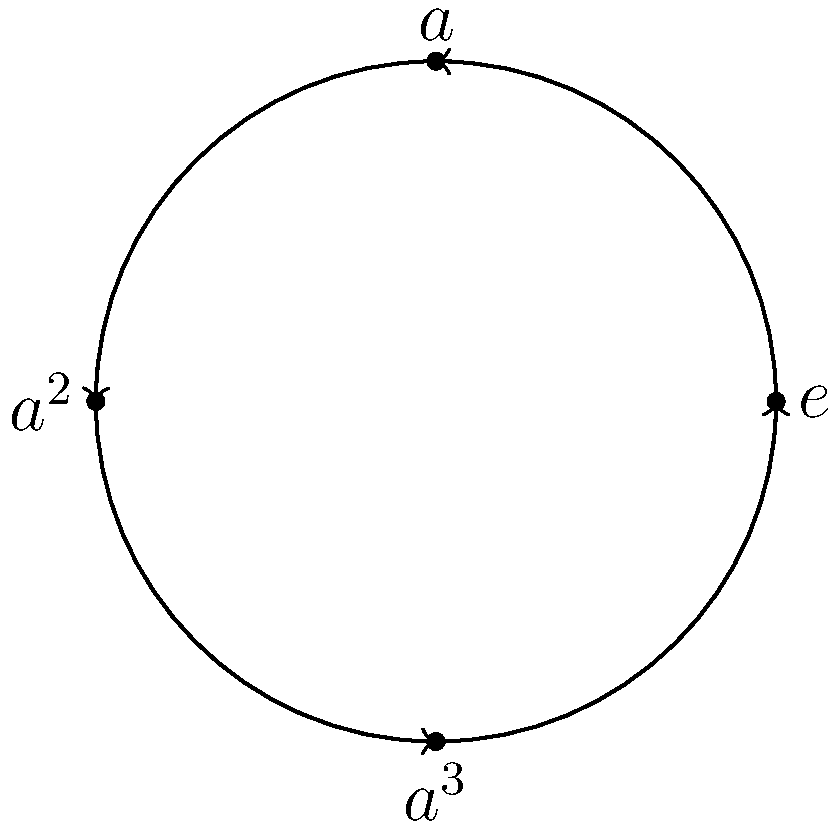In the context of secure software development, consider a cyclic group $C_4$ of order 4 represented by the circular diagram above. If $a$ is a generator of the group, what is the result of $a^5$? To solve this problem, let's follow these steps:

1. Understand the group structure:
   - The group $C_4$ has 4 elements: $e, a, a^2, a^3$
   - $e$ is the identity element
   - $a$ is the generator of the group

2. Recall the properties of cyclic groups:
   - In a cyclic group, any element raised to the order of the group equals the identity element
   - For $C_4$, we have $a^4 = e$

3. Use modular arithmetic:
   - We can express $a^5$ as $a^5 = a^4 \cdot a = e \cdot a = a$
   - Alternatively, we can think of this as $a^5 \equiv a^1 \pmod{4}$, since 5 ≡ 1 (mod 4)

4. Interpret the result:
   - $a^5$ is equivalent to $a$ in this group

This concept is relevant to secure software development as cyclic groups are often used in cryptographic algorithms, such as in the implementation of public-key cryptosystems or in generating pseudo-random numbers for security purposes.
Answer: $a$ 